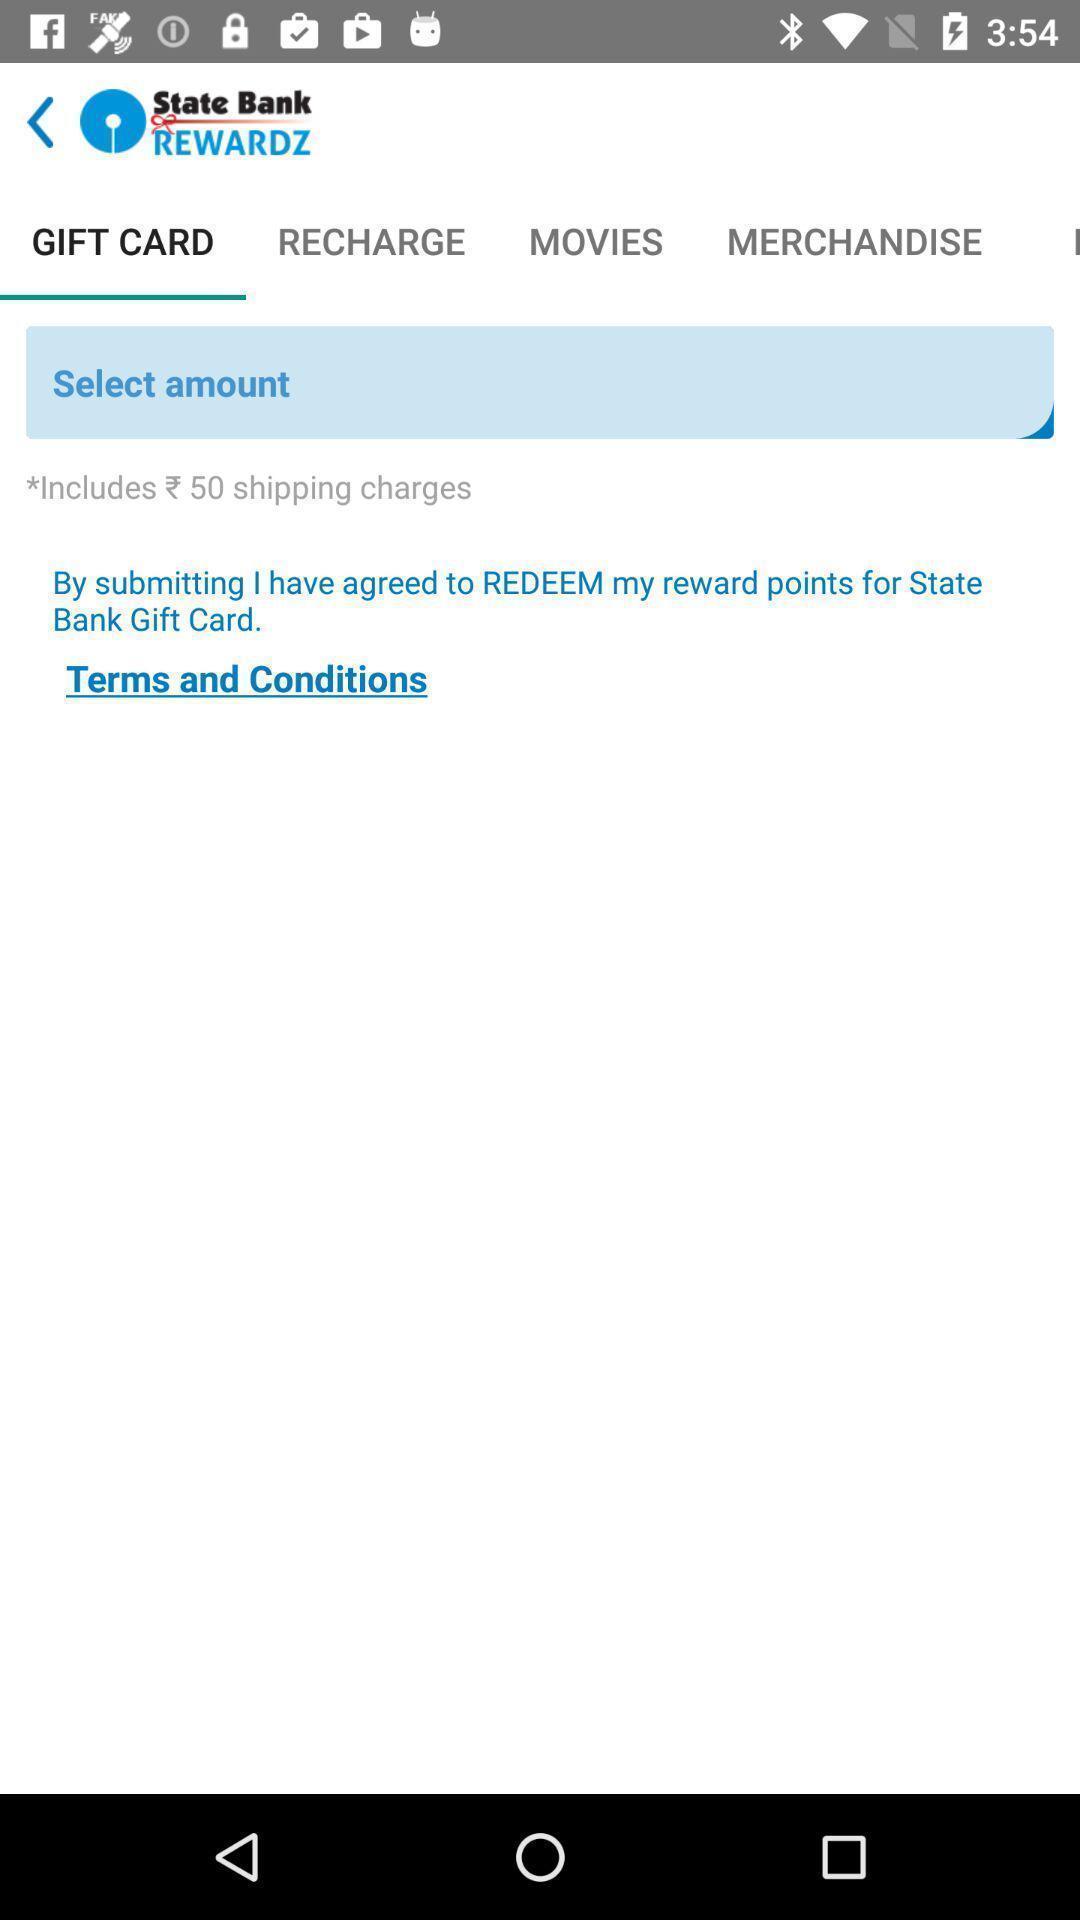What details can you identify in this image? Screen displaying about financial application. 